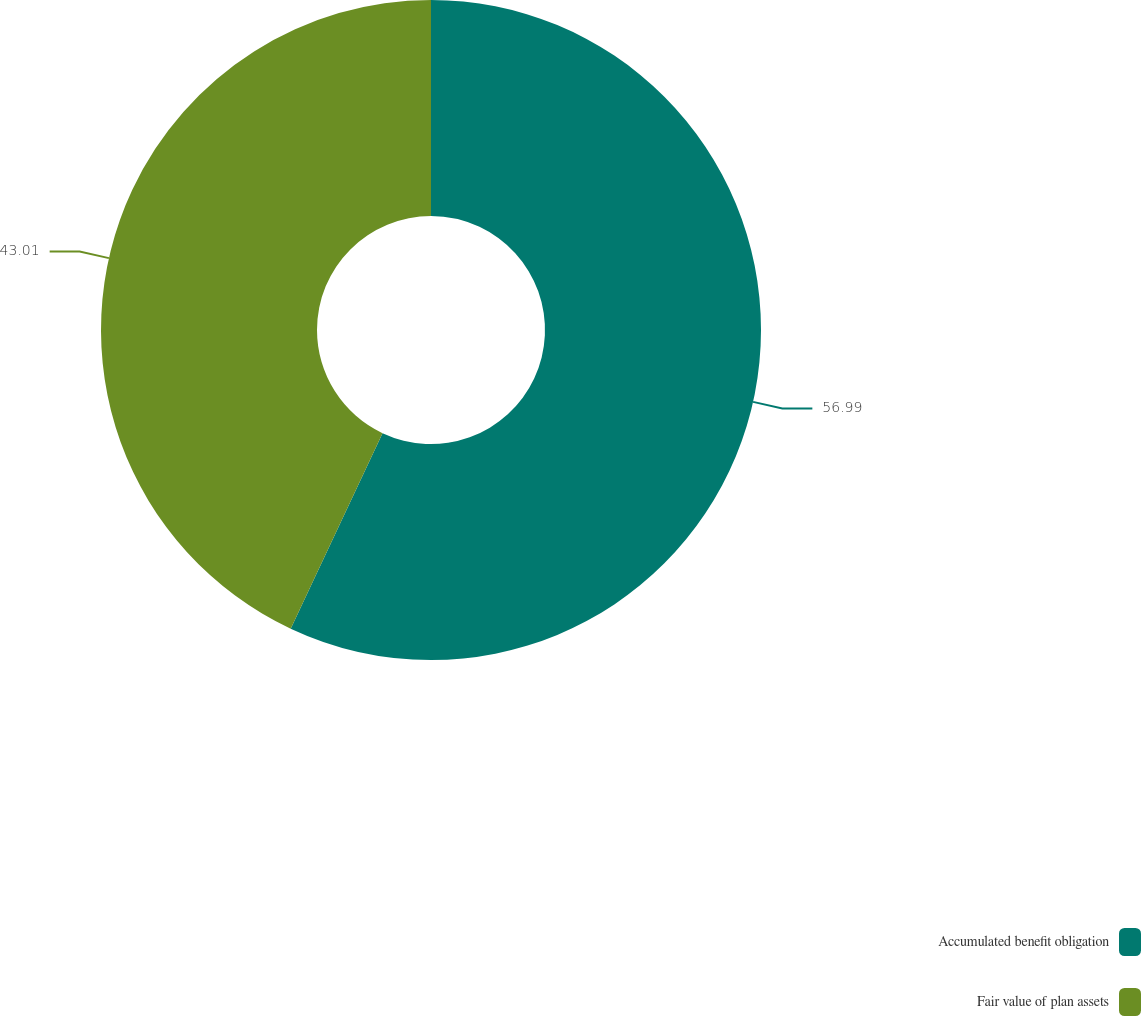Convert chart to OTSL. <chart><loc_0><loc_0><loc_500><loc_500><pie_chart><fcel>Accumulated benefit obligation<fcel>Fair value of plan assets<nl><fcel>56.99%<fcel>43.01%<nl></chart> 